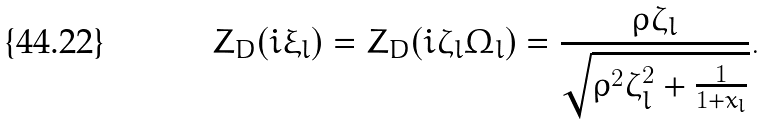<formula> <loc_0><loc_0><loc_500><loc_500>Z _ { D } ( i \xi _ { l } ) = Z _ { D } ( i \zeta _ { l } \Omega _ { l } ) = \frac { \rho \zeta _ { l } } { \sqrt { \rho ^ { 2 } \zeta _ { l } ^ { 2 } + \frac { 1 } { 1 + x _ { l } } } } .</formula> 